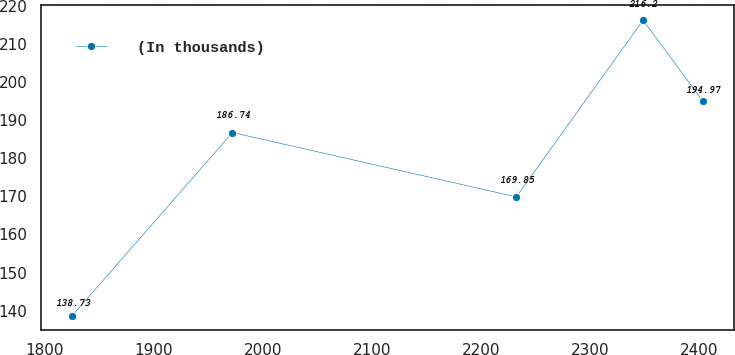Convert chart. <chart><loc_0><loc_0><loc_500><loc_500><line_chart><ecel><fcel>(In thousands)<nl><fcel>1825.35<fcel>138.73<nl><fcel>1972.21<fcel>186.74<nl><fcel>2232.47<fcel>169.85<nl><fcel>2348.8<fcel>216.2<nl><fcel>2403.59<fcel>194.97<nl></chart> 